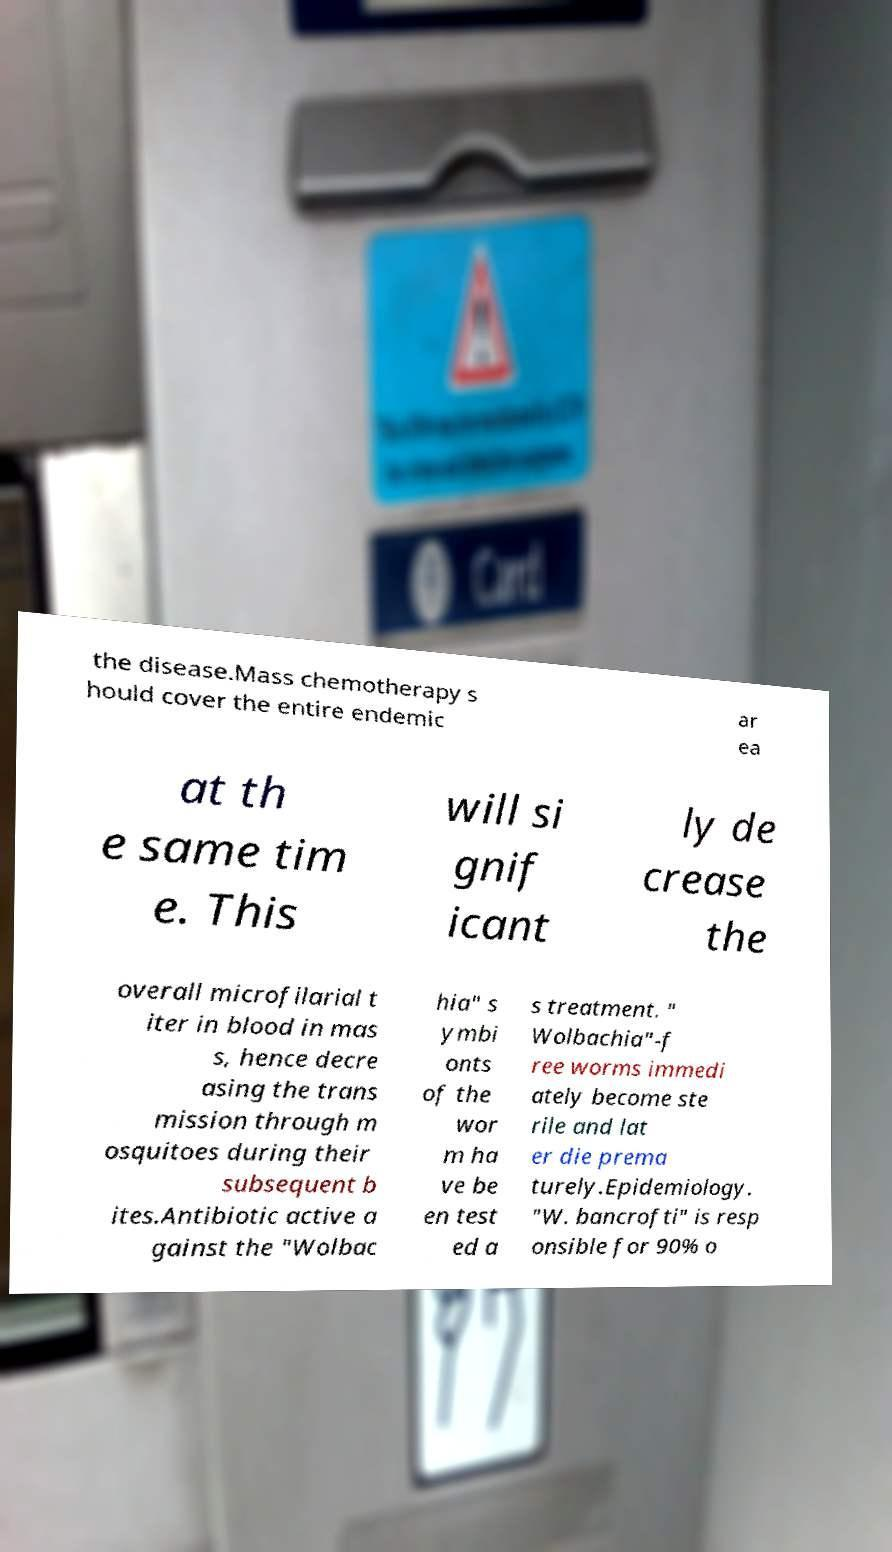Could you assist in decoding the text presented in this image and type it out clearly? the disease.Mass chemotherapy s hould cover the entire endemic ar ea at th e same tim e. This will si gnif icant ly de crease the overall microfilarial t iter in blood in mas s, hence decre asing the trans mission through m osquitoes during their subsequent b ites.Antibiotic active a gainst the "Wolbac hia" s ymbi onts of the wor m ha ve be en test ed a s treatment. " Wolbachia"-f ree worms immedi ately become ste rile and lat er die prema turely.Epidemiology. "W. bancrofti" is resp onsible for 90% o 